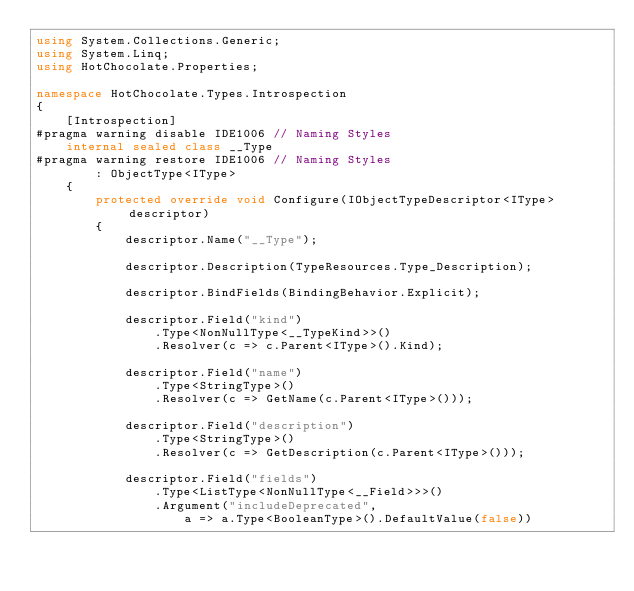<code> <loc_0><loc_0><loc_500><loc_500><_C#_>using System.Collections.Generic;
using System.Linq;
using HotChocolate.Properties;

namespace HotChocolate.Types.Introspection
{
    [Introspection]
#pragma warning disable IDE1006 // Naming Styles
    internal sealed class __Type
#pragma warning restore IDE1006 // Naming Styles
        : ObjectType<IType>
    {
        protected override void Configure(IObjectTypeDescriptor<IType> descriptor)
        {
            descriptor.Name("__Type");

            descriptor.Description(TypeResources.Type_Description);

            descriptor.BindFields(BindingBehavior.Explicit);

            descriptor.Field("kind")
                .Type<NonNullType<__TypeKind>>()
                .Resolver(c => c.Parent<IType>().Kind);

            descriptor.Field("name")
                .Type<StringType>()
                .Resolver(c => GetName(c.Parent<IType>()));

            descriptor.Field("description")
                .Type<StringType>()
                .Resolver(c => GetDescription(c.Parent<IType>()));

            descriptor.Field("fields")
                .Type<ListType<NonNullType<__Field>>>()
                .Argument("includeDeprecated",
                    a => a.Type<BooleanType>().DefaultValue(false))</code> 